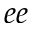Convert formula to latex. <formula><loc_0><loc_0><loc_500><loc_500>e e</formula> 